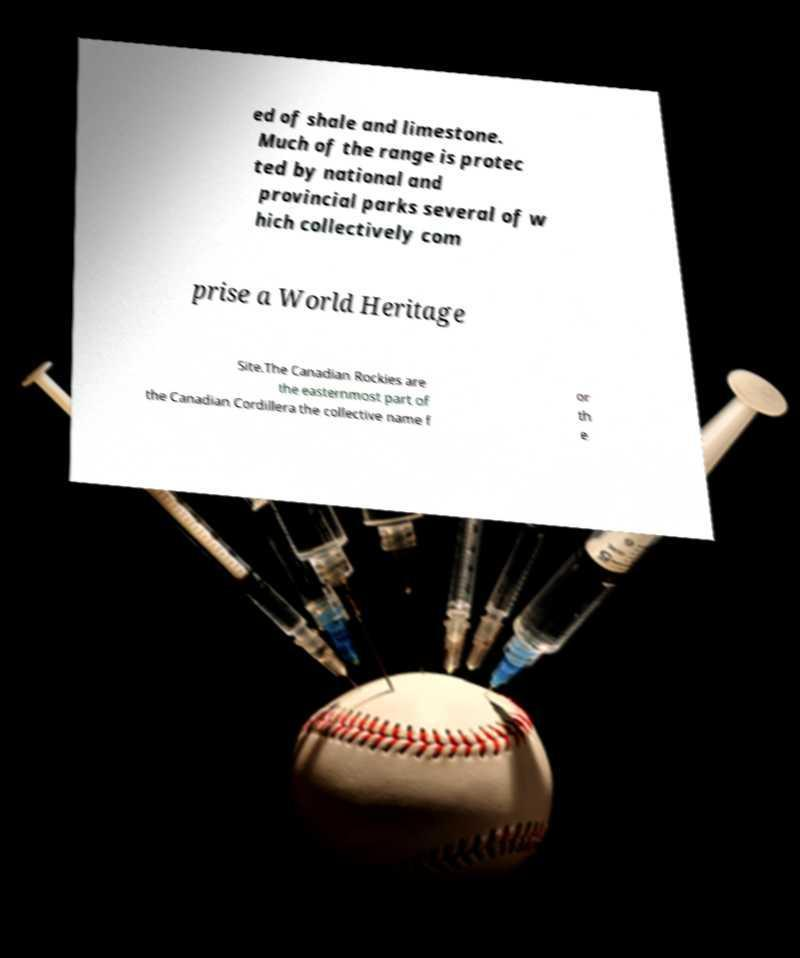I need the written content from this picture converted into text. Can you do that? ed of shale and limestone. Much of the range is protec ted by national and provincial parks several of w hich collectively com prise a World Heritage Site.The Canadian Rockies are the easternmost part of the Canadian Cordillera the collective name f or th e 